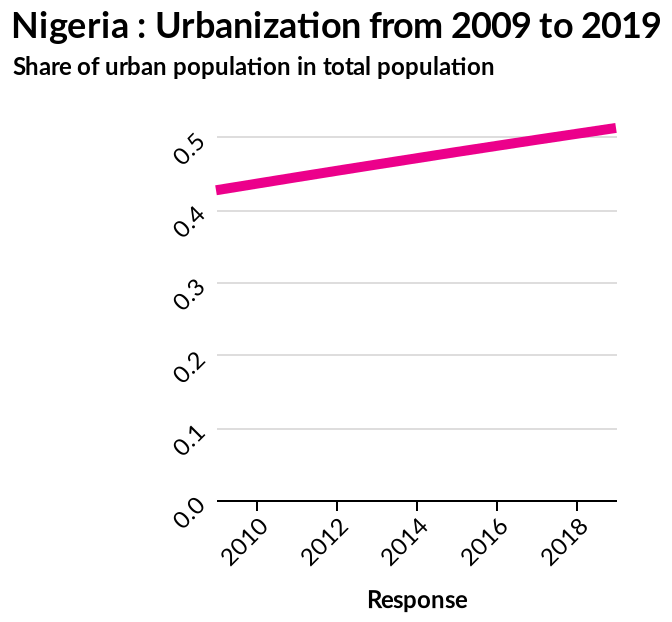<image>
What does the x-axis represent? The x-axis represents the variable "Response" on a linear scale from 2010 to 2018. 